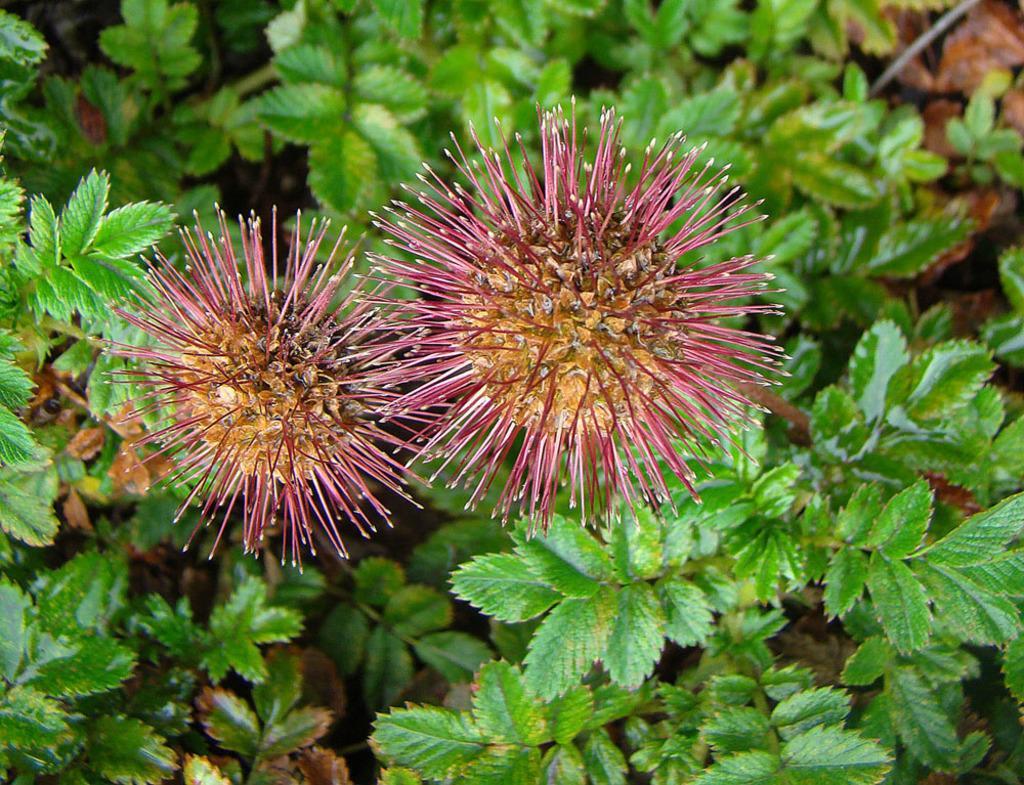In one or two sentences, can you explain what this image depicts? It is a zoomed in picture of bottlebrush plant. 